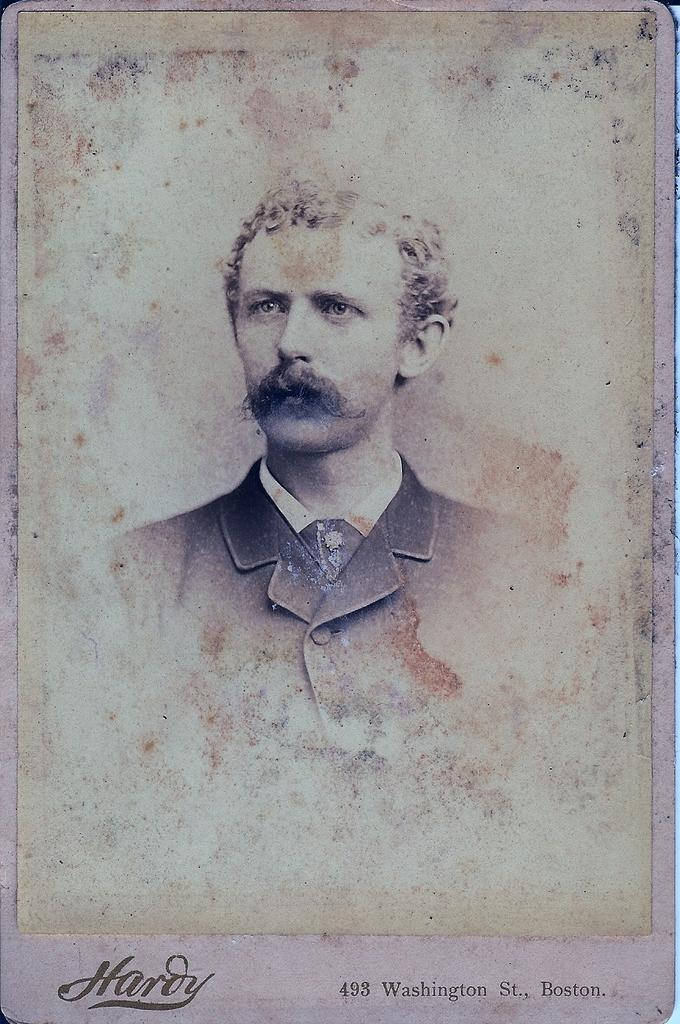What is the main subject of the image? There is a person in the image. Is there any text present in the image? Yes, there is text at the bottom of the image. How would you describe the style of the image? The image is a vintage picture. What type of cheese is being grated by the person in the image? There is no cheese or grating activity present in the image. Can you see the person's elbow in the image? The image does not show the person's elbow; it only shows the person's body from the waist up. 